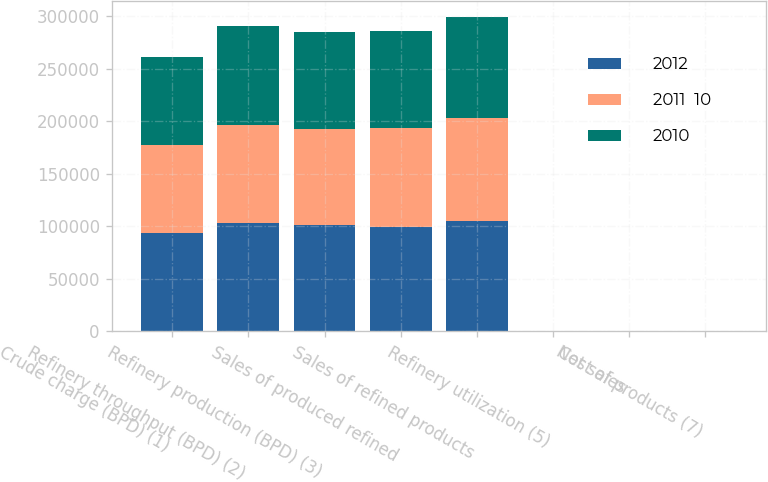Convert chart. <chart><loc_0><loc_0><loc_500><loc_500><stacked_bar_chart><ecel><fcel>Crude charge (BPD) (1)<fcel>Refinery throughput (BPD) (2)<fcel>Refinery production (BPD) (3)<fcel>Sales of produced refined<fcel>Sales of refined products<fcel>Refinery utilization (5)<fcel>Net sales<fcel>Cost of products (7)<nl><fcel>2012<fcel>93830<fcel>103120<fcel>100810<fcel>99160<fcel>104620<fcel>93.8<fcel>122.62<fcel>95.7<nl><fcel>2011  10<fcel>83700<fcel>93260<fcel>91810<fcel>93950<fcel>98540<fcel>83.7<fcel>118.76<fcel>98.4<nl><fcel>2010<fcel>83900<fcel>94270<fcel>92050<fcel>92550<fcel>95790<fcel>83.9<fcel>90.37<fcel>83.12<nl></chart> 